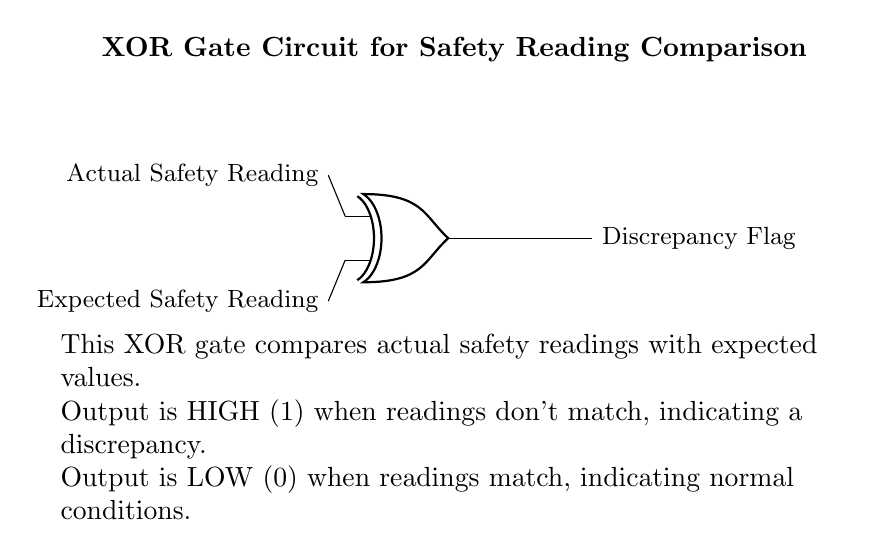What type of logic gate is shown in the circuit? The circuit diagram displays an XOR gate, which is indicated by the shape and labeling in the diagram. XOR gates are characterized by their distinctive symbol and functionality, which is to provide a high output when inputs differ.
Answer: XOR gate What do the input nodes represent in the circuit? The input nodes are labeled as "Actual Safety Reading" and "Expected Safety Reading." This indicates that the inputs to the XOR gate are the measured safety readings and the anticipated safety values.
Answer: Safety readings What does the output signify when it is high? The output of the XOR gate is marked as "Discrepancy Flag." A high output occurs when the actual and expected readings do not match, indicating that there is a discrepancy.
Answer: Discrepancy How many input connections are there to the XOR gate? The diagram clearly shows two input connections coming into the XOR gate, as depicted in the symbolism of the gate itself along with the corresponding input labels.
Answer: Two What condition results in a low output from the XOR gate? A low output occurs when both inputs are the same, meaning the actual and expected safety readings match. The XOR gate only provides a high output when the inputs differ.
Answer: Matching readings What type of relationship does the XOR gate represent with its inputs? The XOR gate exemplifies a relationship where it outputs a high signal if and only if one input is true (high) and the other is false (low). This behavior captures the fundamental comparison occurring between actual and expected readings.
Answer: Exclusive disjunction 